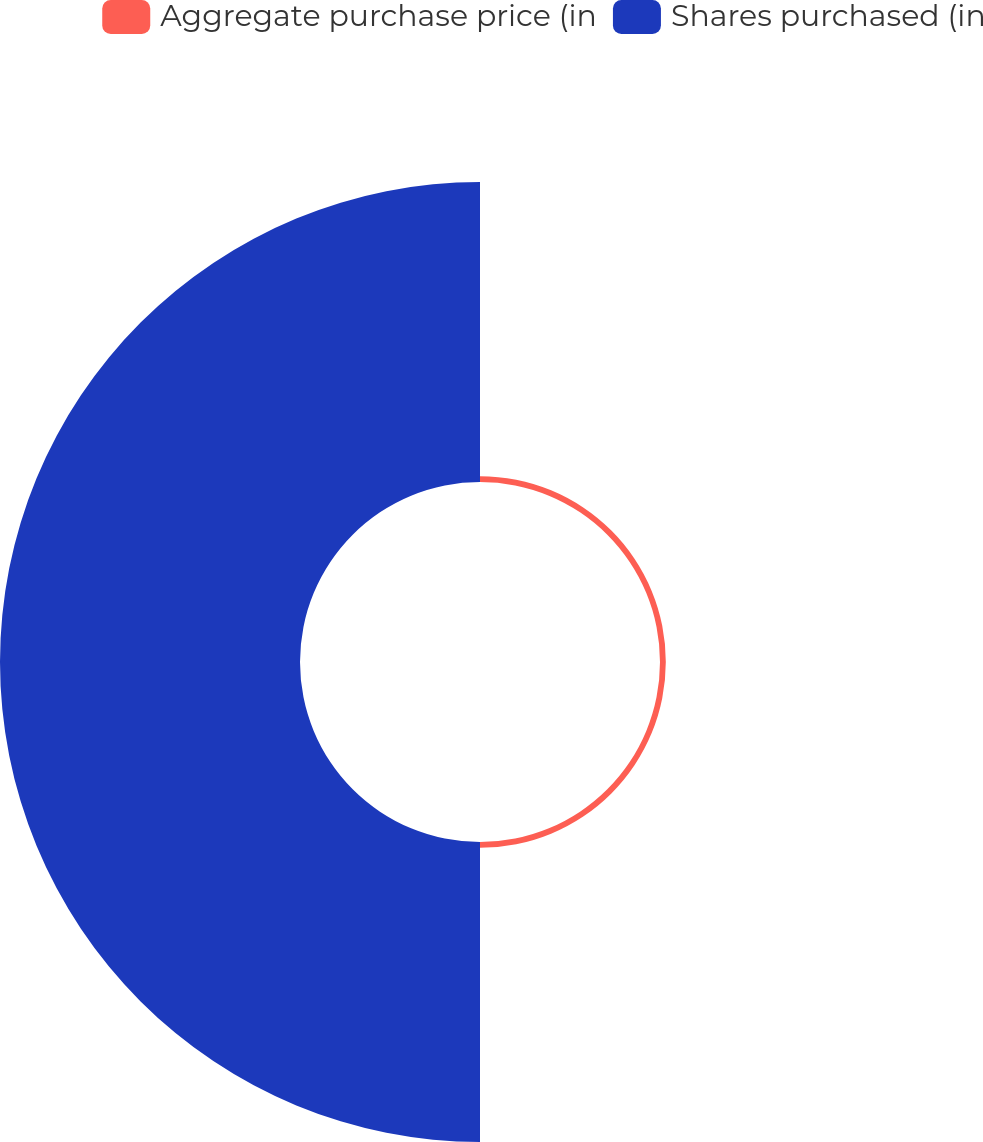Convert chart. <chart><loc_0><loc_0><loc_500><loc_500><pie_chart><fcel>Aggregate purchase price (in<fcel>Shares purchased (in<nl><fcel>1.9%<fcel>98.1%<nl></chart> 